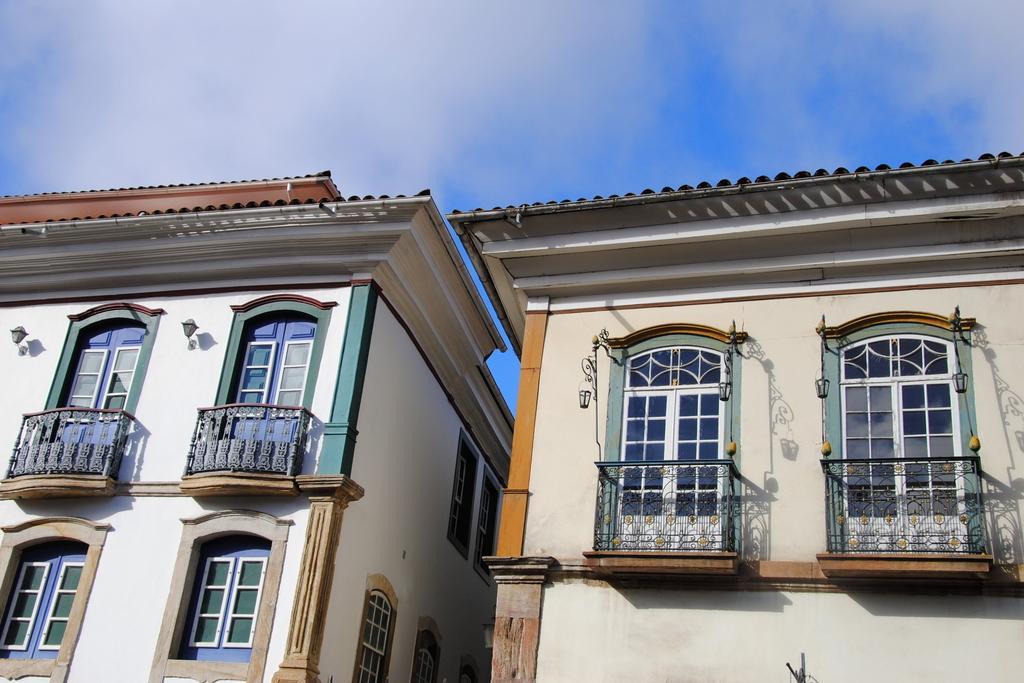How would you summarize this image in a sentence or two? Buildings with windows. Sky is cloudy. 